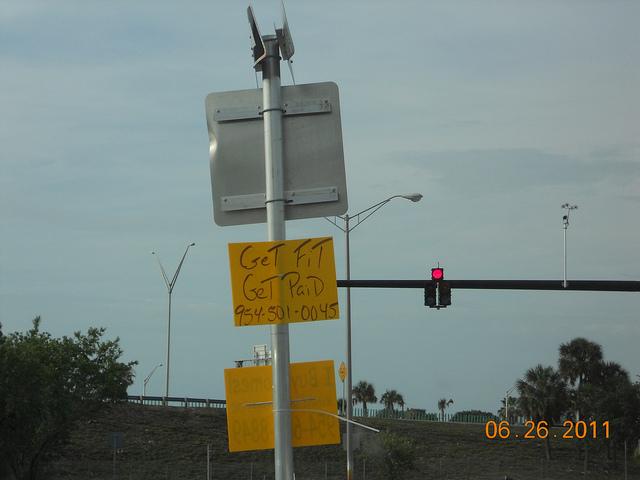What does the camera do?
Write a very short answer. Monitor traffic. What color is the stop light?
Keep it brief. Red. What number should you call if you want to get fit and get paid?
Give a very brief answer. 954-501-0045. Is the day sunny?
Keep it brief. No. What does this do?
Answer briefly. Advertise. How many people in the photo?
Give a very brief answer. 0. What occupation would use this for public safety?
Be succinct. None. 